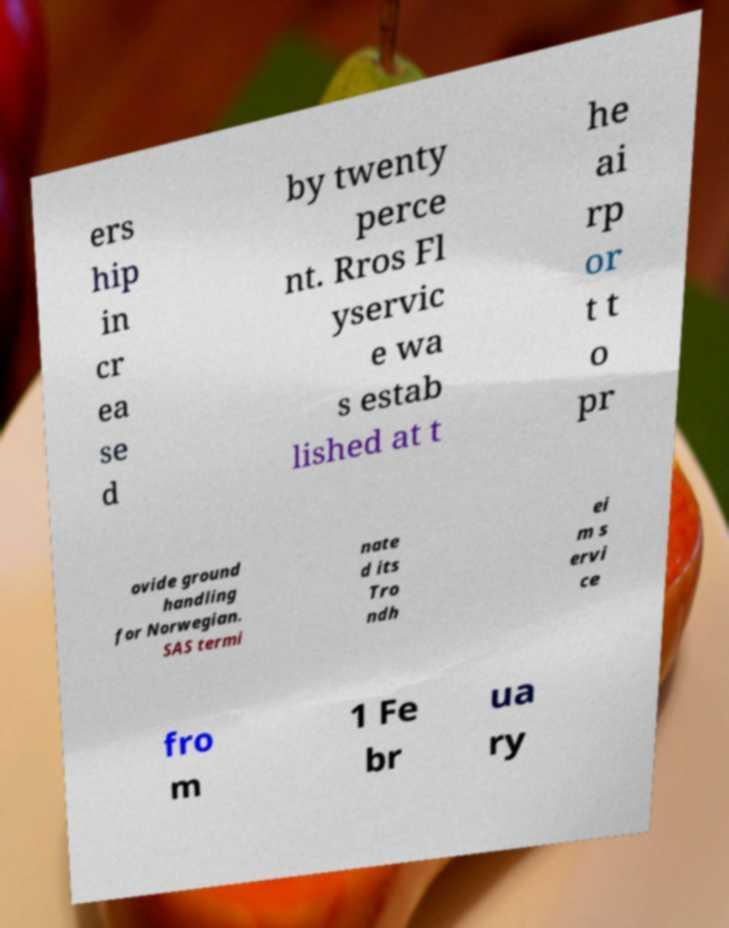Can you read and provide the text displayed in the image?This photo seems to have some interesting text. Can you extract and type it out for me? ers hip in cr ea se d by twenty perce nt. Rros Fl yservic e wa s estab lished at t he ai rp or t t o pr ovide ground handling for Norwegian. SAS termi nate d its Tro ndh ei m s ervi ce fro m 1 Fe br ua ry 